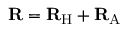Convert formula to latex. <formula><loc_0><loc_0><loc_500><loc_500>{ R } = { R } _ { H } + { R } _ { A }</formula> 